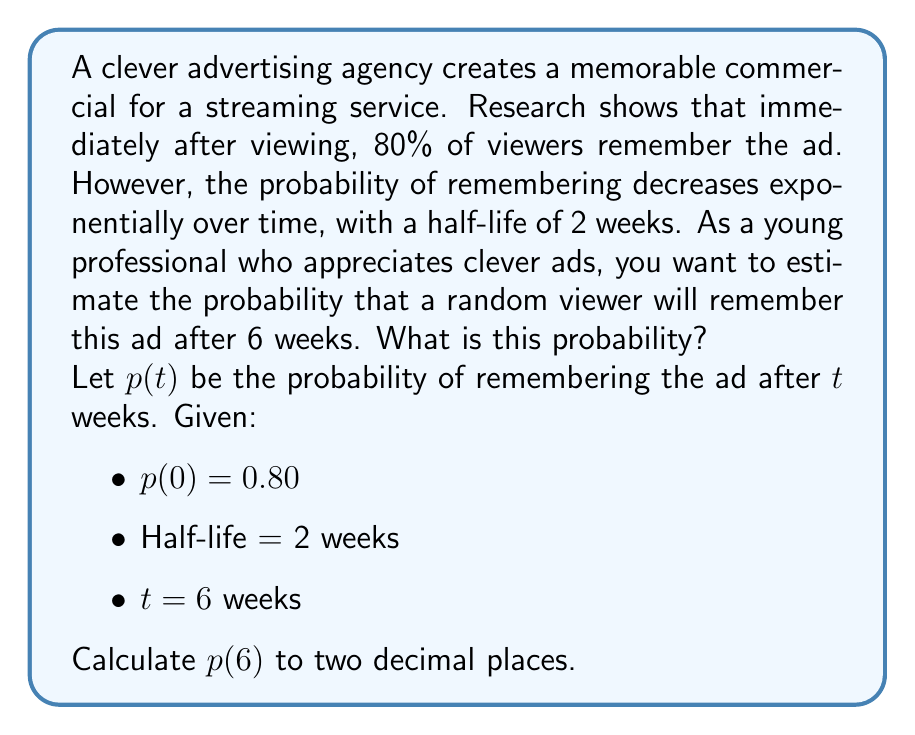What is the answer to this math problem? To solve this problem, we need to use the exponential decay formula:

$$p(t) = p(0) \cdot 2^{-t/h}$$

Where:
- $p(t)$ is the probability of remembering at time $t$
- $p(0)$ is the initial probability (80% or 0.80)
- $t$ is the time elapsed (6 weeks)
- $h$ is the half-life (2 weeks)

Let's substitute these values into the formula:

$$p(6) = 0.80 \cdot 2^{-6/2}$$

Now, let's solve step by step:

1) Simplify the exponent:
   $$p(6) = 0.80 \cdot 2^{-3}$$

2) Calculate $2^{-3}$:
   $$2^{-3} = \frac{1}{2^3} = \frac{1}{8} = 0.125$$

3) Multiply:
   $$p(6) = 0.80 \cdot 0.125 = 0.1$$

Therefore, the probability of a random viewer remembering the ad after 6 weeks is 0.1 or 10%.
Answer: 0.10 or 10% 